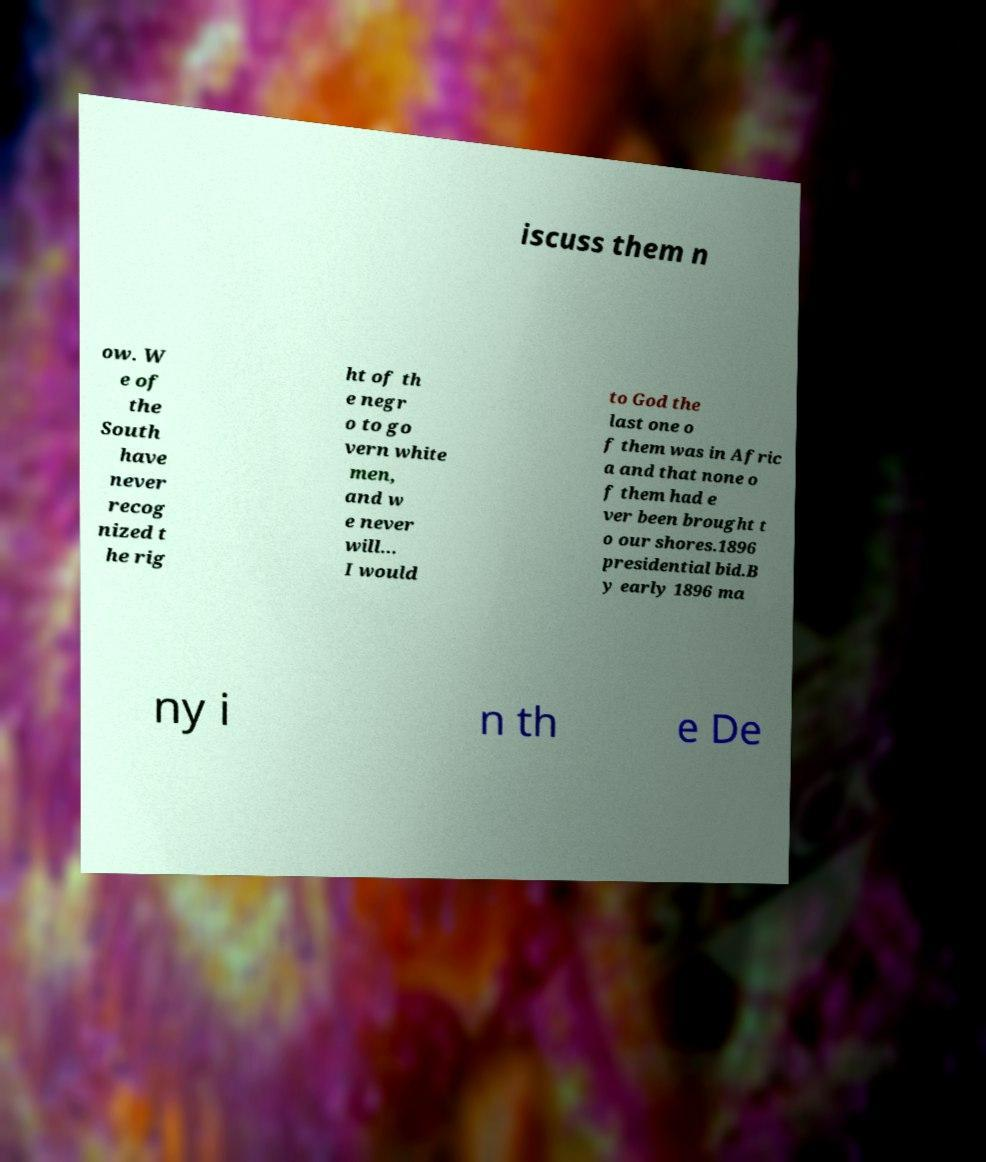Could you assist in decoding the text presented in this image and type it out clearly? iscuss them n ow. W e of the South have never recog nized t he rig ht of th e negr o to go vern white men, and w e never will... I would to God the last one o f them was in Afric a and that none o f them had e ver been brought t o our shores.1896 presidential bid.B y early 1896 ma ny i n th e De 